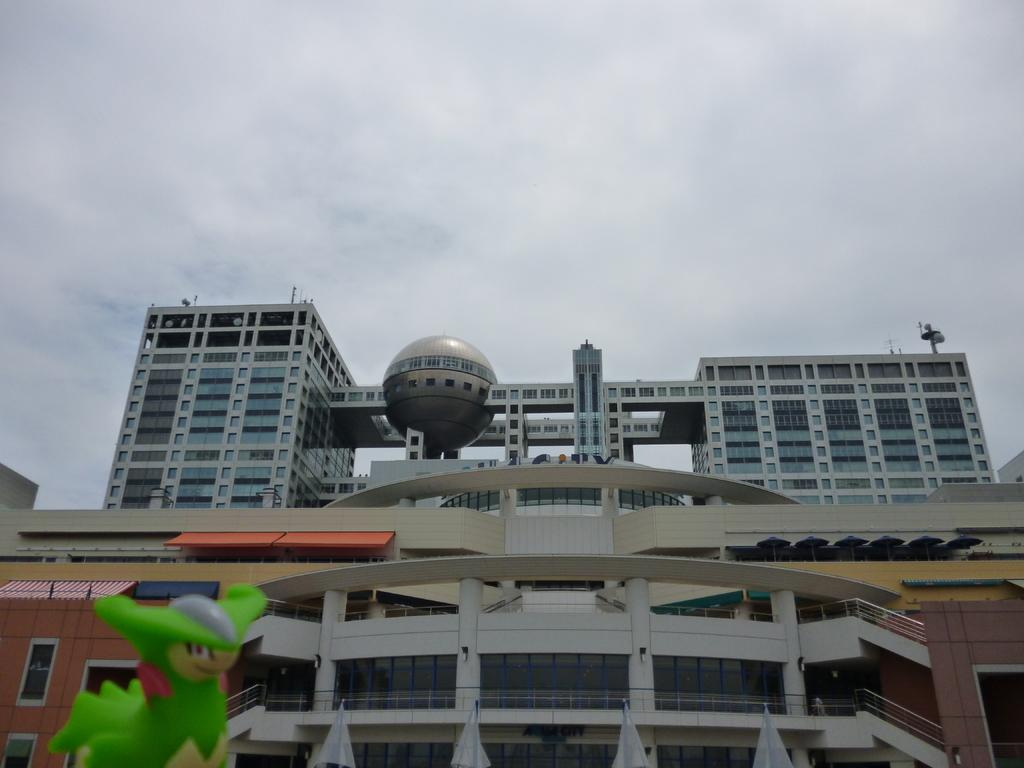What type of structures can be seen in the image? There are buildings in the image. What material is used for the rods in the image? Metal rods are present in the image. What objects are on top of the buildings? There are umbrellas on the buildings. What nerve is responsible for the movement of the umbrellas in the image? There is no nerve responsible for the movement of the umbrellas in the image, as they are stationary objects. 